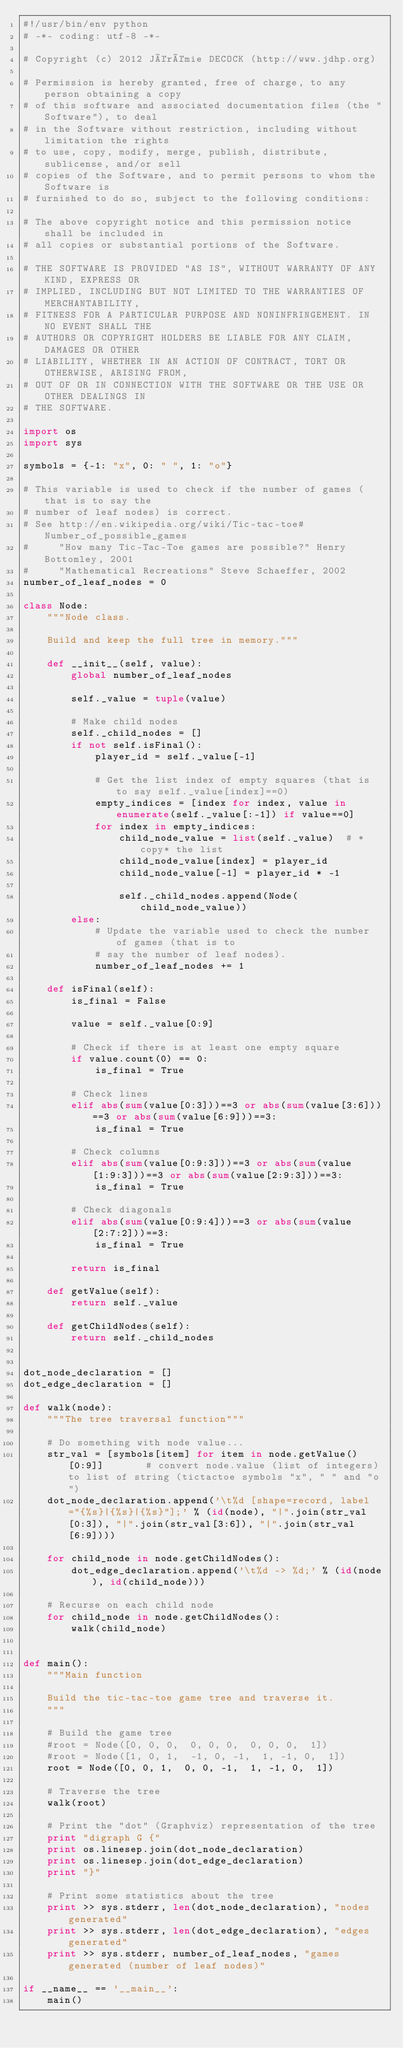<code> <loc_0><loc_0><loc_500><loc_500><_Python_>#!/usr/bin/env python
# -*- coding: utf-8 -*-

# Copyright (c) 2012 Jérémie DECOCK (http://www.jdhp.org)

# Permission is hereby granted, free of charge, to any person obtaining a copy
# of this software and associated documentation files (the "Software"), to deal
# in the Software without restriction, including without limitation the rights
# to use, copy, modify, merge, publish, distribute, sublicense, and/or sell
# copies of the Software, and to permit persons to whom the Software is
# furnished to do so, subject to the following conditions:

# The above copyright notice and this permission notice shall be included in
# all copies or substantial portions of the Software.
 
# THE SOFTWARE IS PROVIDED "AS IS", WITHOUT WARRANTY OF ANY KIND, EXPRESS OR
# IMPLIED, INCLUDING BUT NOT LIMITED TO THE WARRANTIES OF MERCHANTABILITY,
# FITNESS FOR A PARTICULAR PURPOSE AND NONINFRINGEMENT. IN NO EVENT SHALL THE
# AUTHORS OR COPYRIGHT HOLDERS BE LIABLE FOR ANY CLAIM, DAMAGES OR OTHER
# LIABILITY, WHETHER IN AN ACTION OF CONTRACT, TORT OR OTHERWISE, ARISING FROM,
# OUT OF OR IN CONNECTION WITH THE SOFTWARE OR THE USE OR OTHER DEALINGS IN
# THE SOFTWARE.

import os
import sys

symbols = {-1: "x", 0: " ", 1: "o"}

# This variable is used to check if the number of games (that is to say the
# number of leaf nodes) is correct.
# See http://en.wikipedia.org/wiki/Tic-tac-toe#Number_of_possible_games
#     "How many Tic-Tac-Toe games are possible?" Henry Bottomley, 2001
#     "Mathematical Recreations" Steve Schaeffer, 2002
number_of_leaf_nodes = 0

class Node:
    """Node class.
    
    Build and keep the full tree in memory."""

    def __init__(self, value):
        global number_of_leaf_nodes

        self._value = tuple(value)

        # Make child nodes
        self._child_nodes = []
        if not self.isFinal():
            player_id = self._value[-1]

            # Get the list index of empty squares (that is to say self._value[index]==0)
            empty_indices = [index for index, value in enumerate(self._value[:-1]) if value==0]
            for index in empty_indices:
                child_node_value = list(self._value)  # *copy* the list
                child_node_value[index] = player_id
                child_node_value[-1] = player_id * -1
                
                self._child_nodes.append(Node(child_node_value))
        else:
            # Update the variable used to check the number of games (that is to
            # say the number of leaf nodes).
            number_of_leaf_nodes += 1

    def isFinal(self):
        is_final = False

        value = self._value[0:9]

        # Check if there is at least one empty square
        if value.count(0) == 0:
            is_final = True

        # Check lines
        elif abs(sum(value[0:3]))==3 or abs(sum(value[3:6]))==3 or abs(sum(value[6:9]))==3:
            is_final = True

        # Check columns
        elif abs(sum(value[0:9:3]))==3 or abs(sum(value[1:9:3]))==3 or abs(sum(value[2:9:3]))==3:
            is_final = True

        # Check diagonals
        elif abs(sum(value[0:9:4]))==3 or abs(sum(value[2:7:2]))==3:
            is_final = True

        return is_final

    def getValue(self):
        return self._value

    def getChildNodes(self):
        return self._child_nodes


dot_node_declaration = []
dot_edge_declaration = []

def walk(node):
    """The tree traversal function"""

    # Do something with node value...
    str_val = [symbols[item] for item in node.getValue()[0:9]]       # convert node.value (list of integers) to list of string (tictactoe symbols "x", " " and "o")
    dot_node_declaration.append('\t%d [shape=record, label="{%s}|{%s}|{%s}"];' % (id(node), "|".join(str_val[0:3]), "|".join(str_val[3:6]), "|".join(str_val[6:9])))

    for child_node in node.getChildNodes():
        dot_edge_declaration.append('\t%d -> %d;' % (id(node), id(child_node)))

    # Recurse on each child node
    for child_node in node.getChildNodes():
        walk(child_node)


def main():
    """Main function

    Build the tic-tac-toe game tree and traverse it.
    """

    # Build the game tree
    #root = Node([0, 0, 0,  0, 0, 0,  0, 0, 0,  1])
    #root = Node([1, 0, 1,  -1, 0, -1,  1, -1, 0,  1])
    root = Node([0, 0, 1,  0, 0, -1,  1, -1, 0,  1])

    # Traverse the tree
    walk(root)

    # Print the "dot" (Graphviz) representation of the tree
    print "digraph G {"
    print os.linesep.join(dot_node_declaration)
    print os.linesep.join(dot_edge_declaration)
    print "}"

    # Print some statistics about the tree
    print >> sys.stderr, len(dot_node_declaration), "nodes generated"
    print >> sys.stderr, len(dot_edge_declaration), "edges generated"
    print >> sys.stderr, number_of_leaf_nodes, "games generated (number of leaf nodes)"

if __name__ == '__main__':
    main()

</code> 